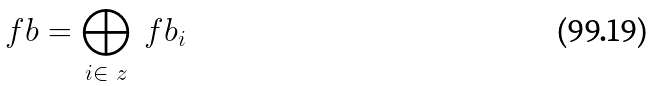Convert formula to latex. <formula><loc_0><loc_0><loc_500><loc_500>\ f b = \bigoplus _ { i \in \ z } \ f b _ { i }</formula> 